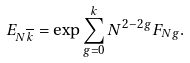Convert formula to latex. <formula><loc_0><loc_0><loc_500><loc_500>E _ { N \overline { k } } = \exp \sum _ { g = 0 } ^ { k } N ^ { 2 - 2 g } F _ { N g } .</formula> 